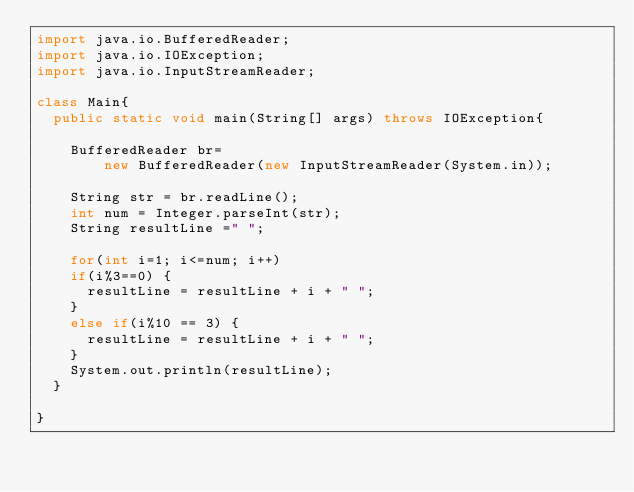<code> <loc_0><loc_0><loc_500><loc_500><_Java_>import java.io.BufferedReader;
import java.io.IOException;
import java.io.InputStreamReader;

class Main{
	public static void main(String[] args) throws IOException{
		
		BufferedReader br=
				new BufferedReader(new InputStreamReader(System.in));
		
		String str = br.readLine();
		int num = Integer.parseInt(str);
		String resultLine =" ";
		
		for(int i=1; i<=num; i++)
		if(i%3==0) {
			resultLine = resultLine + i + " ";
		}
		else if(i%10 == 3) {
			resultLine = resultLine + i + " ";
		}
		System.out.println(resultLine);
	}

}</code> 